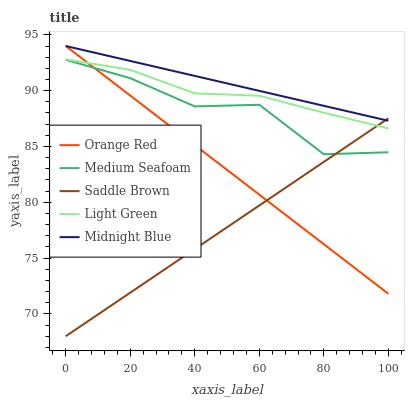Does Saddle Brown have the minimum area under the curve?
Answer yes or no. Yes. Does Midnight Blue have the maximum area under the curve?
Answer yes or no. Yes. Does Orange Red have the minimum area under the curve?
Answer yes or no. No. Does Orange Red have the maximum area under the curve?
Answer yes or no. No. Is Orange Red the smoothest?
Answer yes or no. Yes. Is Medium Seafoam the roughest?
Answer yes or no. Yes. Is Midnight Blue the smoothest?
Answer yes or no. No. Is Midnight Blue the roughest?
Answer yes or no. No. Does Saddle Brown have the lowest value?
Answer yes or no. Yes. Does Orange Red have the lowest value?
Answer yes or no. No. Does Orange Red have the highest value?
Answer yes or no. Yes. Does Light Green have the highest value?
Answer yes or no. No. Is Medium Seafoam less than Light Green?
Answer yes or no. Yes. Is Midnight Blue greater than Light Green?
Answer yes or no. Yes. Does Orange Red intersect Midnight Blue?
Answer yes or no. Yes. Is Orange Red less than Midnight Blue?
Answer yes or no. No. Is Orange Red greater than Midnight Blue?
Answer yes or no. No. Does Medium Seafoam intersect Light Green?
Answer yes or no. No. 